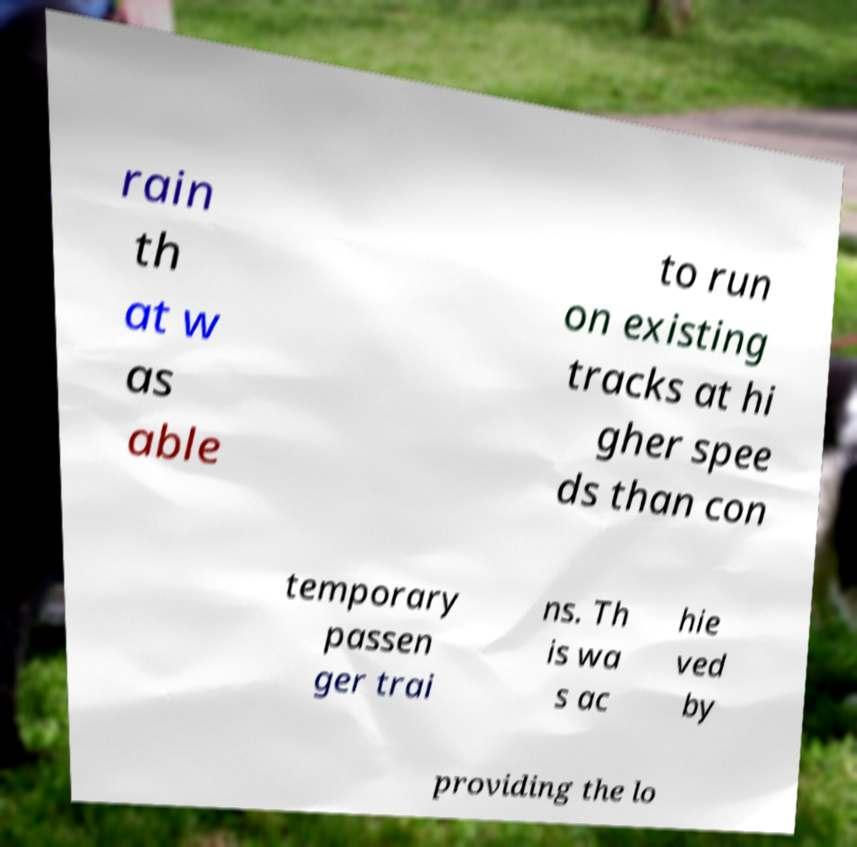Please identify and transcribe the text found in this image. rain th at w as able to run on existing tracks at hi gher spee ds than con temporary passen ger trai ns. Th is wa s ac hie ved by providing the lo 